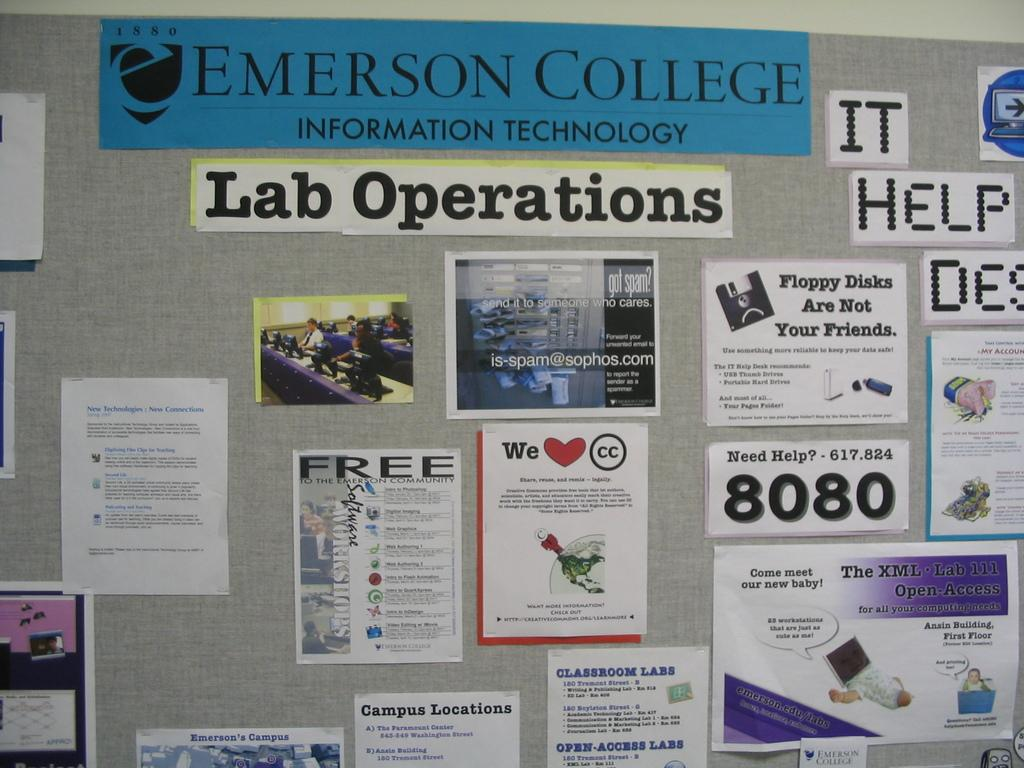<image>
Describe the image concisely. Emerson College Information Technology and Lab Operations on a board. 